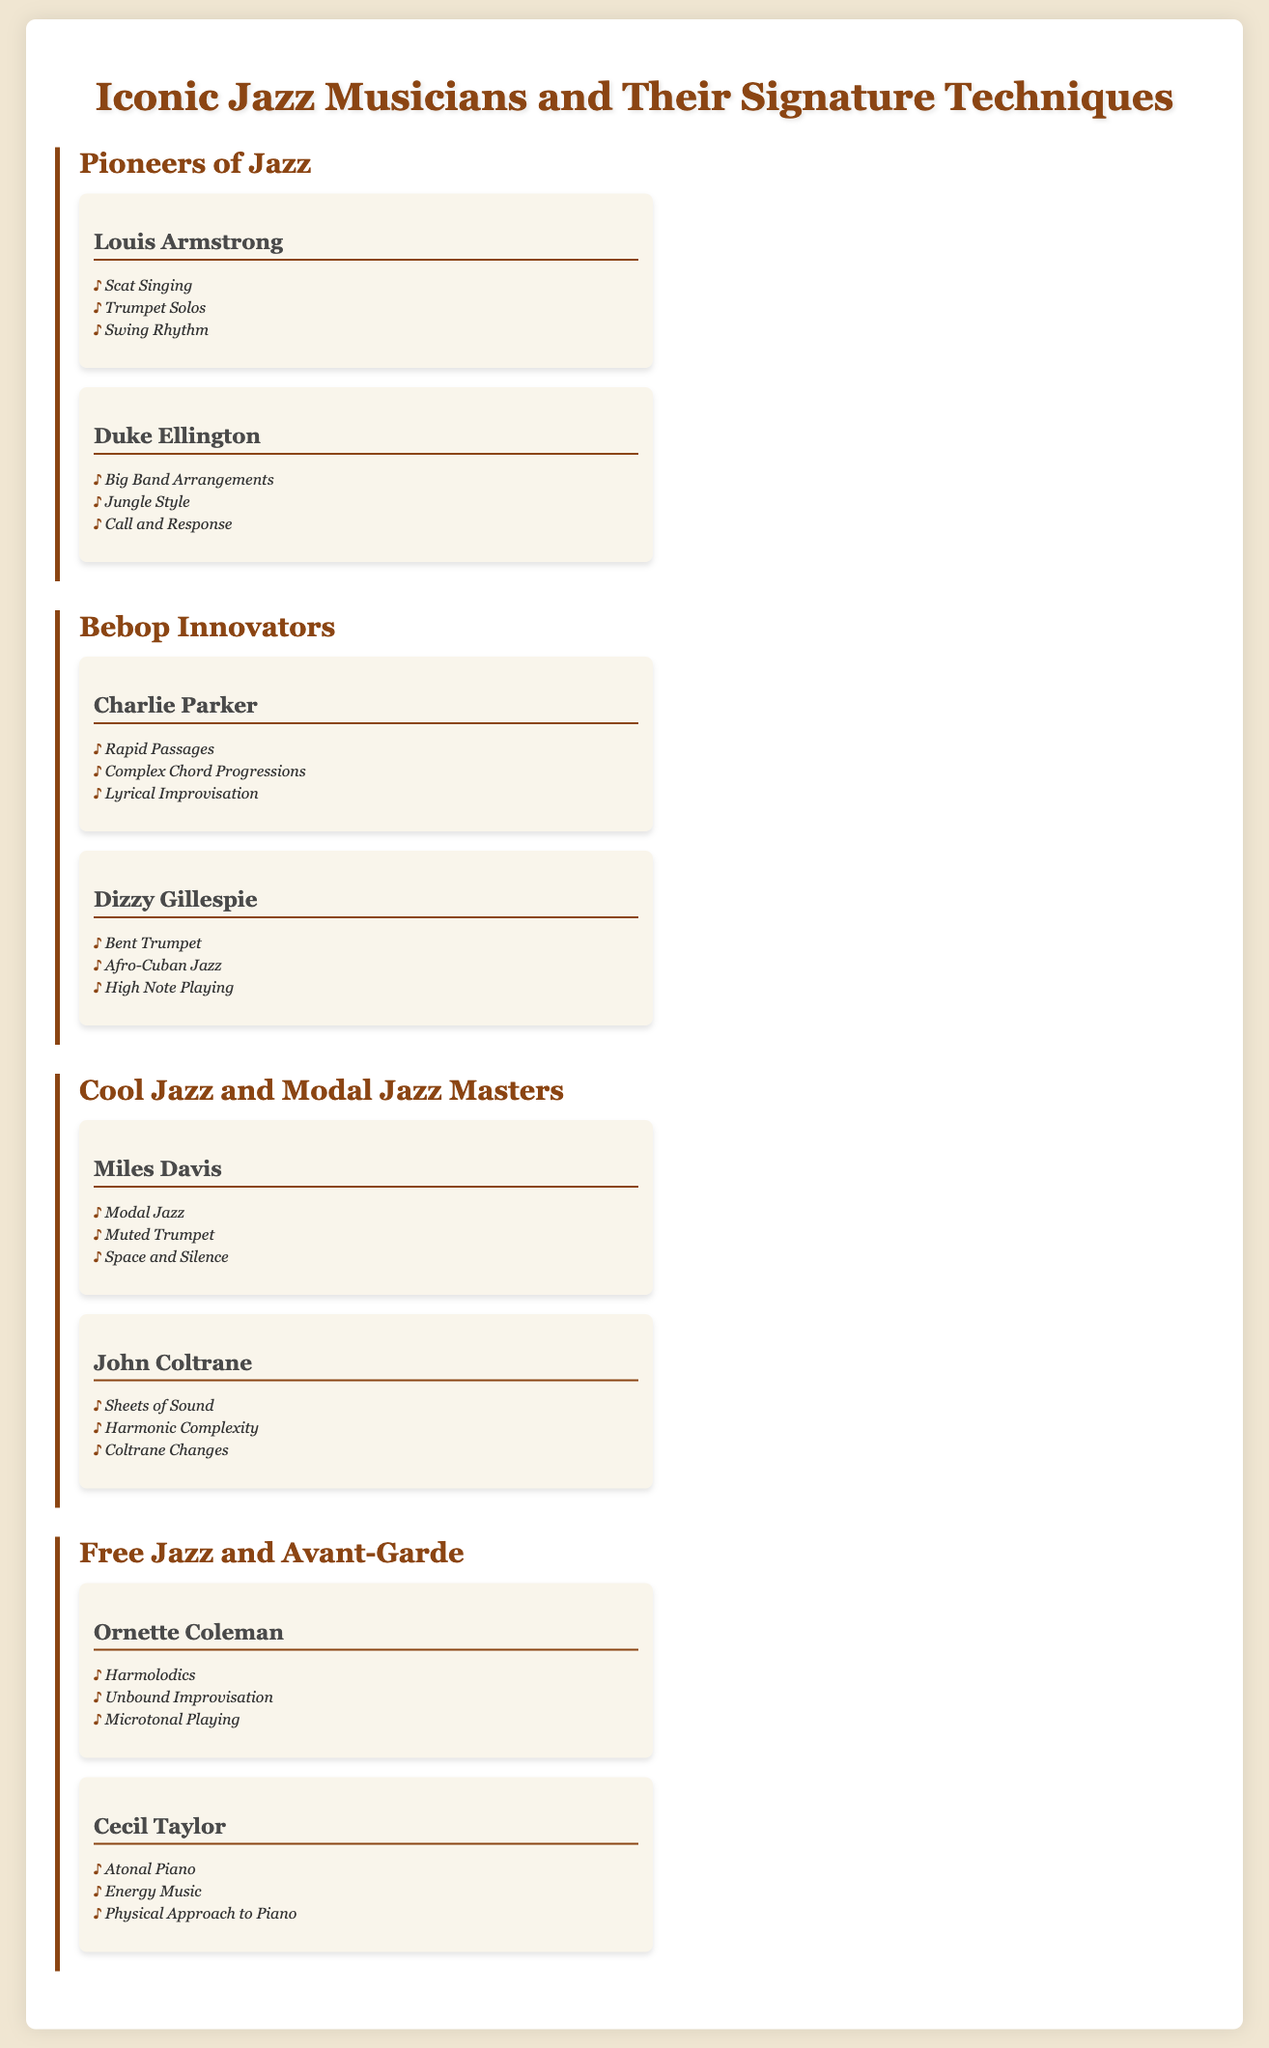What is the title of the infographic? The title of the infographic is prominently displayed at the top, introducing the main subject matter.
Answer: Iconic Jazz Musicians and Their Signature Techniques How many categories are there in the document? The document presents multiple sections, each labeled as a distinct category.
Answer: Four Name one signature technique of Louis Armstrong. Louis Armstrong is listed with multiple techniques, showcasing his significant contributions to jazz music.
Answer: Scat Singing Who is associated with "Sheets of Sound"? The document links specific techniques to their respective musicians, indicating who is known for particular styles.
Answer: John Coltrane What is a technique used by Ornette Coleman? The infographic provides specific techniques attributed to various musicians, highlighting their unique contributions.
Answer: Harmolodics Which musician is known for "Complex Chord Progressions"? This information requires connecting the musician to their distinctive musical approach as described in the document.
Answer: Charlie Parker What performance style does Cecil Taylor represent? The document categorizes different jazz musicians and their innovative styles, reflecting their artistic expressions.
Answer: Atonal Piano 